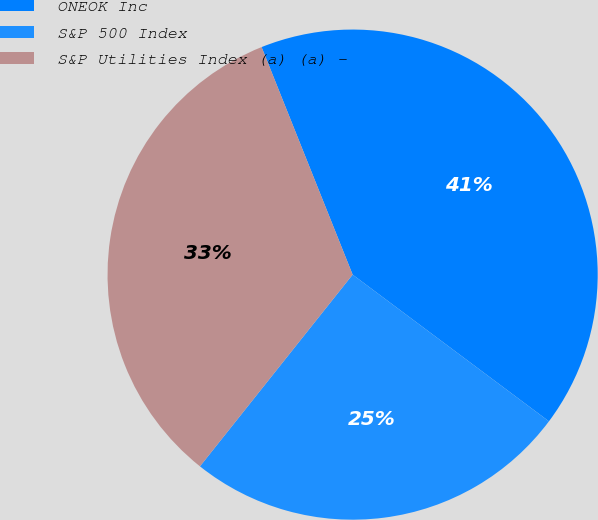Convert chart. <chart><loc_0><loc_0><loc_500><loc_500><pie_chart><fcel>ONEOK Inc<fcel>S&P 500 Index<fcel>S&P Utilities Index (a) (a) -<nl><fcel>41.27%<fcel>25.49%<fcel>33.24%<nl></chart> 